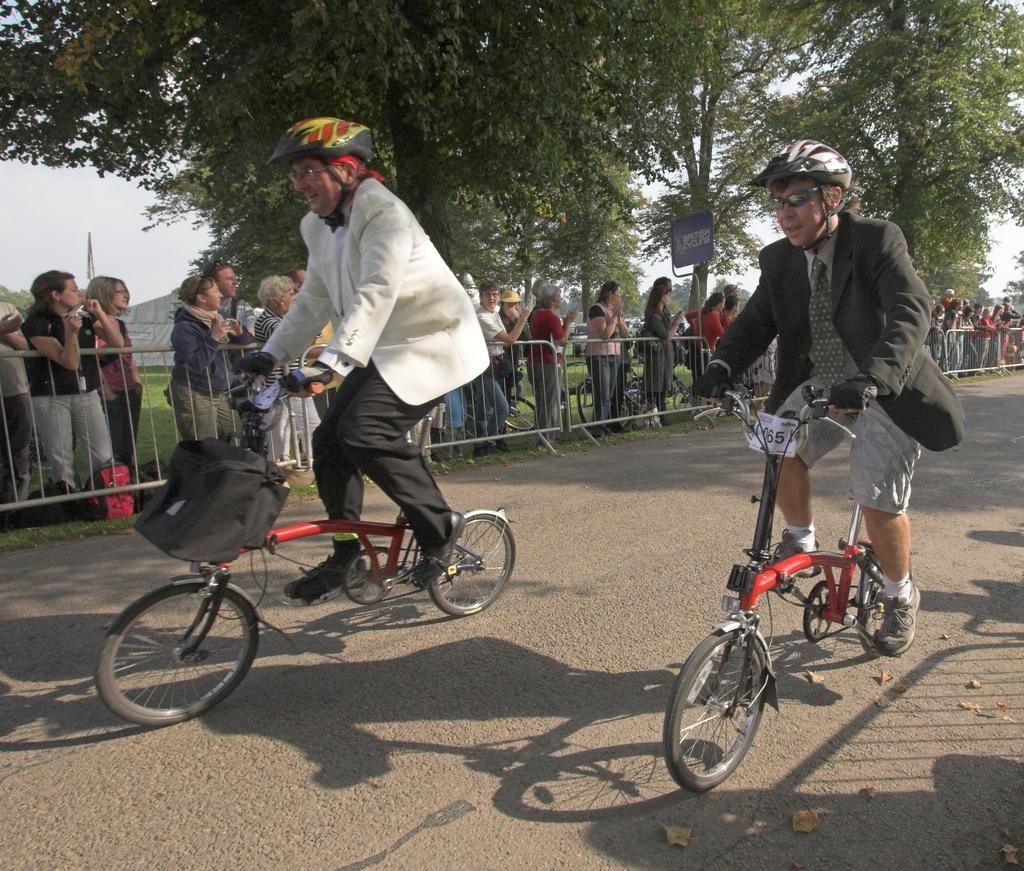What are the two persons in the image doing? The two persons in the image are riding bicycles on the road. What can be seen in the background of the image? There is fencing in the image. What else is happening in the image? There is a group of people standing in the image. What is visible in the sky in the image? The sky is visible in the image. What type of breakfast is being served to the planes in the image? There are no planes or breakfast present in the image. 